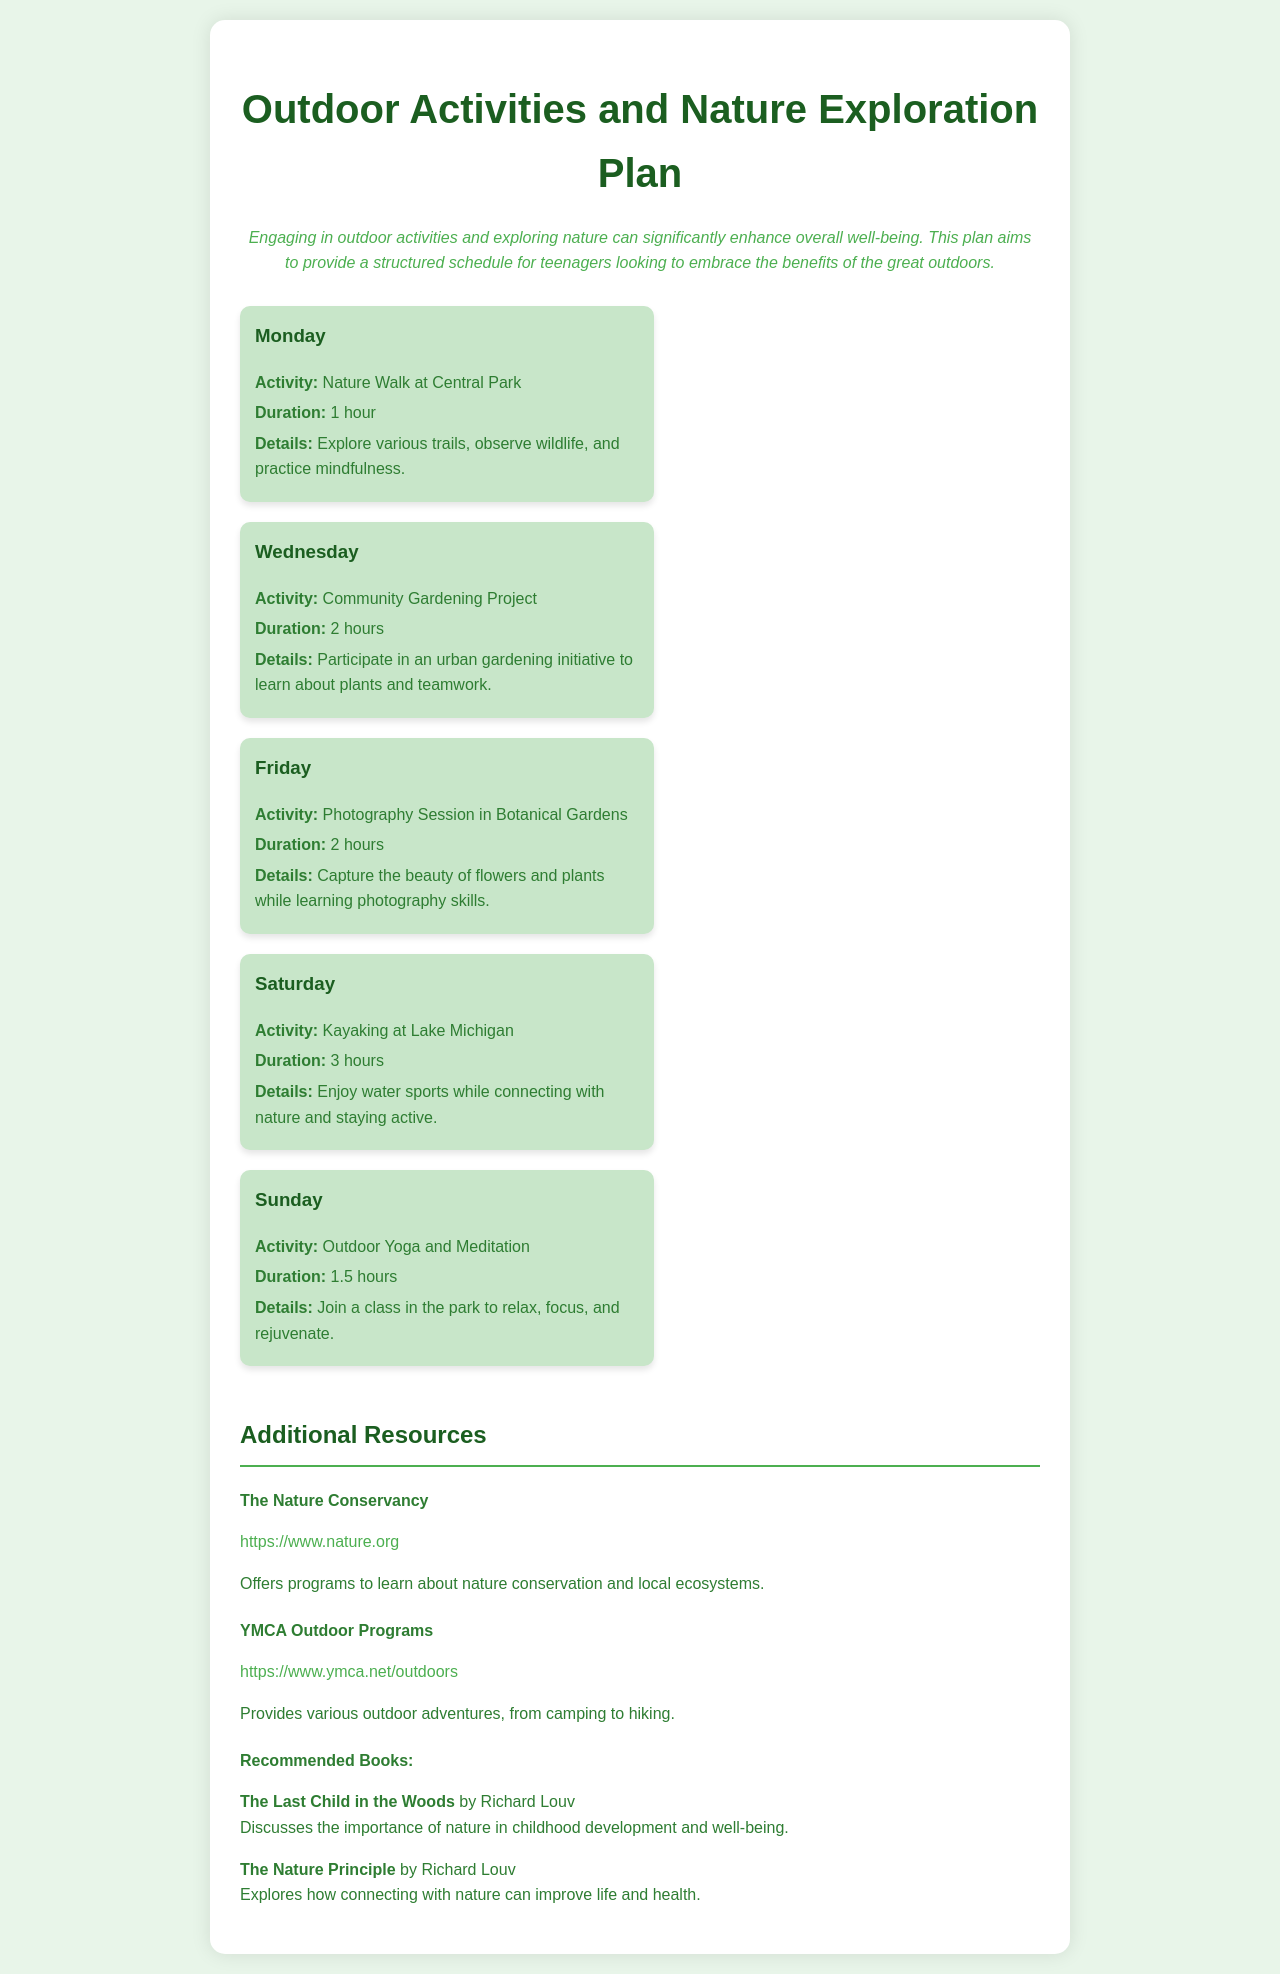What is the first activity listed for the week? The document outlines the schedule of activities for the week with the first activity on Monday being a nature walk at Central Park.
Answer: Nature Walk at Central Park How long is the kayaking activity scheduled for? The kayaking activity on Saturday has a designated duration of 3 hours, as stated in the schedule.
Answer: 3 hours What day includes outdoor yoga and meditation? The document specifies that outdoor yoga and meditation sessions occur on Sunday.
Answer: Sunday What type of project is planned for Wednesday? Wednesday's activity is identified as a community gardening project, involving urban gardening initiatives.
Answer: Community Gardening Project How many hours is the photography session scheduled for? The photography session in botanical gardens scheduled for Friday is noted to last for 2 hours in the document.
Answer: 2 hours Which activity focuses on teamwork? The community gardening project scheduled for Wednesday is designed to encourage teamwork among participants.
Answer: Community Gardening Project What is the main benefit of engaging in these activities according to the document? The introduction emphasizes that engaging in outdoor activities significantly enhances overall well-being, which serves as the primary benefit.
Answer: Overall well-being How many outdoor activities are listed in the schedule? The document outlines a total of five outdoor activities included in the weekly schedule.
Answer: Five What is the purpose of the additional resources section? The additional resources section provides links and information for further engagement with outdoor programs and nature-related materials.
Answer: Further engagement 